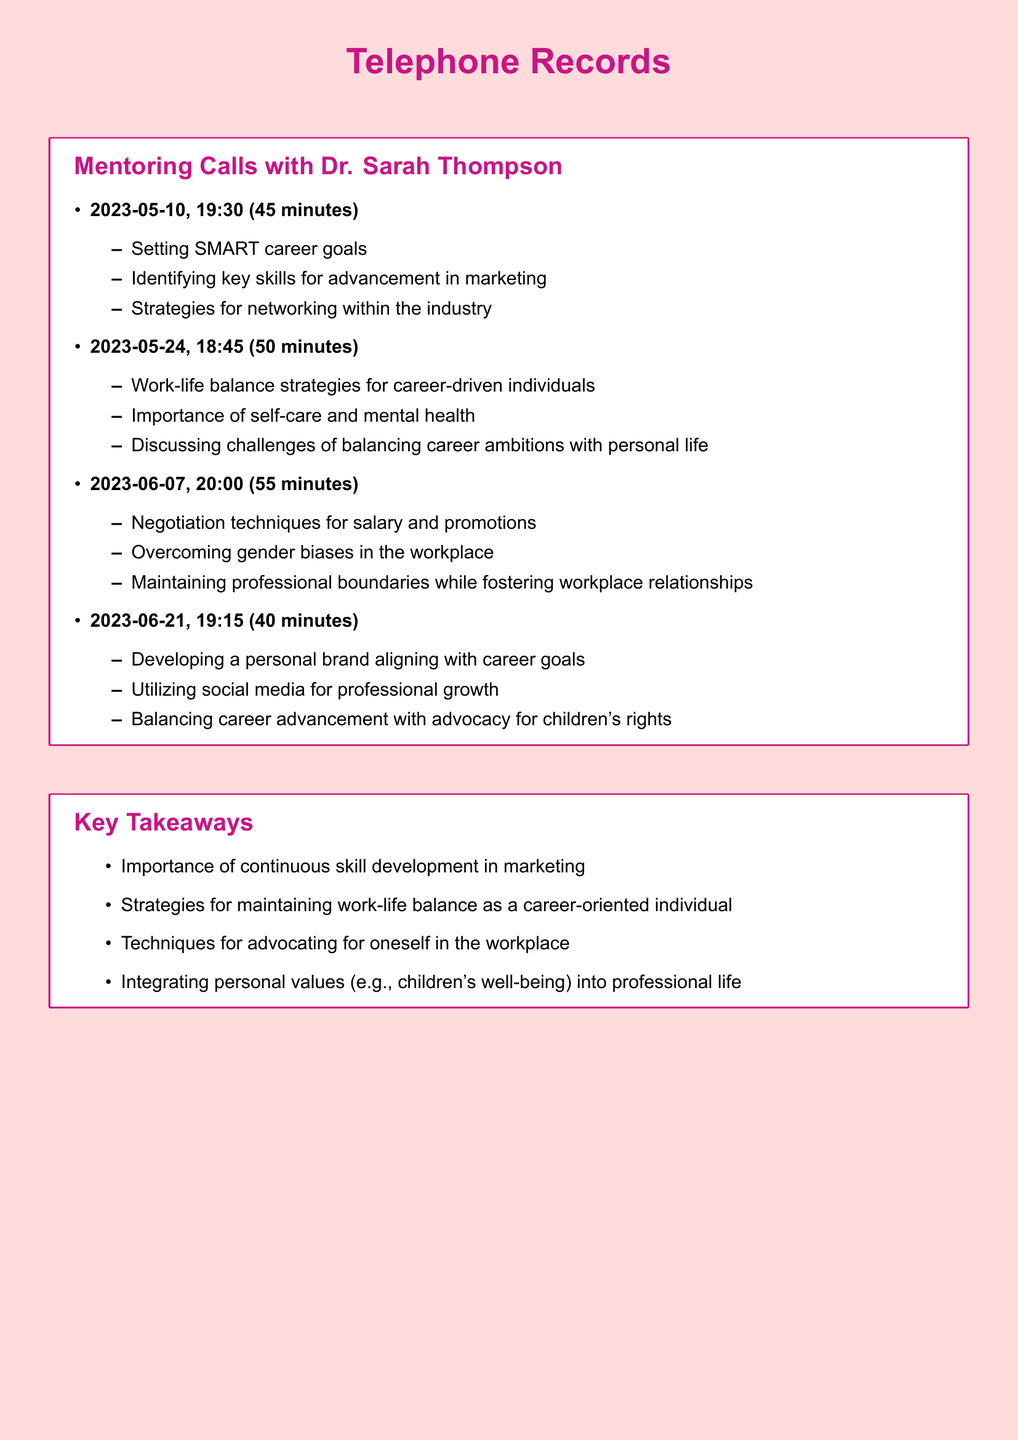What is the date of the first call? The first call took place on May 10, 2023.
Answer: May 10, 2023 How long did the second call last? The duration of the second call was 50 minutes long.
Answer: 50 minutes Who is the mentor mentioned in the records? The mentor's name listed in the records is Dr. Sarah Thompson.
Answer: Dr. Sarah Thompson What was discussed in the third call? The third call covered negotiation techniques, gender biases, and maintaining professional boundaries.
Answer: Negotiation techniques, gender biases, maintaining professional boundaries How many calls were recorded in total? There are a total of four calls documented in the records.
Answer: Four What is one strategy for work-life balance mentioned? One strategy discussed for work-life balance is the importance of self-care and mental health.
Answer: Self-care and mental health When was the last call made? The last recorded call took place on June 21, 2023.
Answer: June 21, 2023 What key takeaway relates to children's rights? The takeaway that relates to children's rights is balancing career advancement with advocacy for children's rights.
Answer: Balancing career advancement with advocacy for children's rights 